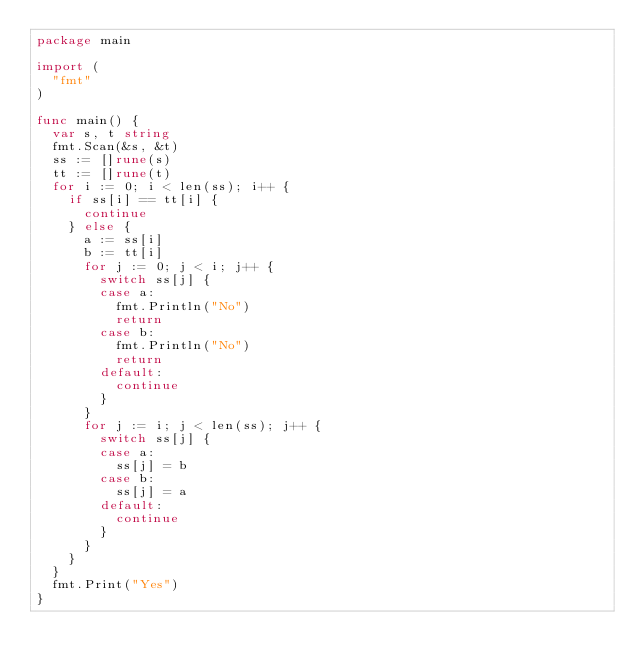<code> <loc_0><loc_0><loc_500><loc_500><_Go_>package main

import (
	"fmt"
)

func main() {
	var s, t string
	fmt.Scan(&s, &t)
	ss := []rune(s)
	tt := []rune(t)
	for i := 0; i < len(ss); i++ {
		if ss[i] == tt[i] {
			continue
		} else {
			a := ss[i]
			b := tt[i]
			for j := 0; j < i; j++ {
				switch ss[j] {
				case a:
					fmt.Println("No")
					return
				case b:
					fmt.Println("No")
					return
				default:
					continue
				}
			}
			for j := i; j < len(ss); j++ {
				switch ss[j] {
				case a:
					ss[j] = b
				case b:
					ss[j] = a
				default:
					continue
				}
			}
		}
	}
	fmt.Print("Yes")
}
</code> 